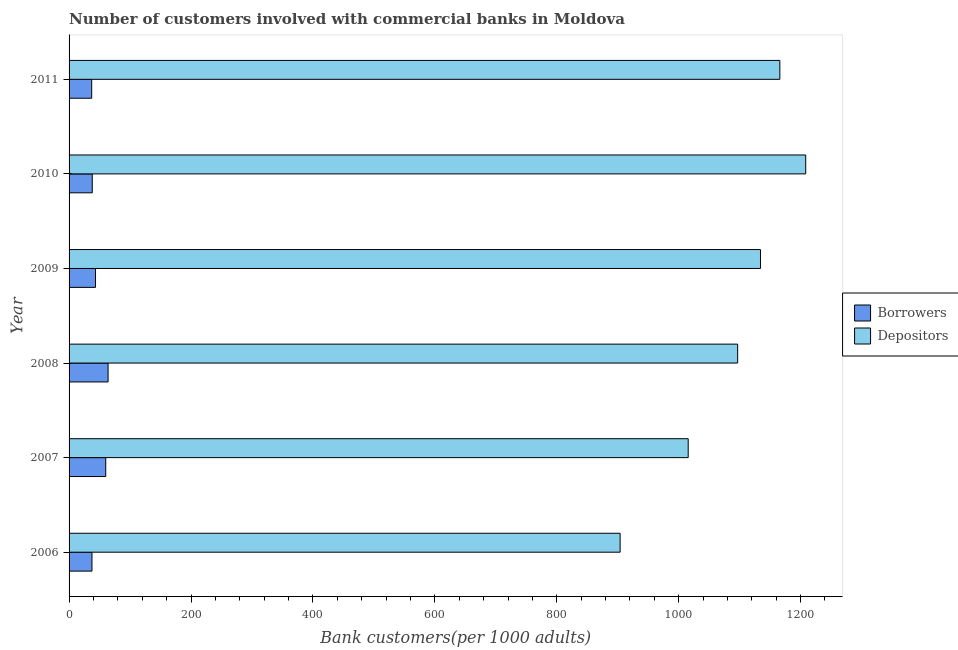How many groups of bars are there?
Your answer should be compact. 6. How many bars are there on the 4th tick from the bottom?
Make the answer very short. 2. What is the label of the 2nd group of bars from the top?
Your response must be concise. 2010. What is the number of borrowers in 2006?
Offer a very short reply. 37.56. Across all years, what is the maximum number of borrowers?
Keep it short and to the point. 63.99. Across all years, what is the minimum number of depositors?
Your answer should be very brief. 903.95. In which year was the number of depositors minimum?
Your response must be concise. 2006. What is the total number of depositors in the graph?
Ensure brevity in your answer.  6524.78. What is the difference between the number of borrowers in 2006 and that in 2007?
Your answer should be compact. -22.58. What is the difference between the number of depositors in 2006 and the number of borrowers in 2008?
Ensure brevity in your answer.  839.96. What is the average number of depositors per year?
Provide a succinct answer. 1087.46. In the year 2007, what is the difference between the number of borrowers and number of depositors?
Keep it short and to the point. -955.47. In how many years, is the number of depositors greater than 920 ?
Offer a very short reply. 5. What is the ratio of the number of borrowers in 2008 to that in 2010?
Your response must be concise. 1.68. What is the difference between the highest and the second highest number of depositors?
Provide a short and direct response. 42.46. What is the difference between the highest and the lowest number of depositors?
Offer a very short reply. 304.44. In how many years, is the number of borrowers greater than the average number of borrowers taken over all years?
Give a very brief answer. 2. Is the sum of the number of depositors in 2007 and 2010 greater than the maximum number of borrowers across all years?
Your response must be concise. Yes. What does the 2nd bar from the top in 2010 represents?
Ensure brevity in your answer.  Borrowers. What does the 1st bar from the bottom in 2008 represents?
Keep it short and to the point. Borrowers. How many bars are there?
Provide a succinct answer. 12. Are all the bars in the graph horizontal?
Provide a short and direct response. Yes. How many years are there in the graph?
Offer a terse response. 6. Are the values on the major ticks of X-axis written in scientific E-notation?
Give a very brief answer. No. Does the graph contain any zero values?
Offer a terse response. No. Does the graph contain grids?
Make the answer very short. No. How many legend labels are there?
Your answer should be compact. 2. What is the title of the graph?
Your answer should be very brief. Number of customers involved with commercial banks in Moldova. Does "% of GNI" appear as one of the legend labels in the graph?
Give a very brief answer. No. What is the label or title of the X-axis?
Make the answer very short. Bank customers(per 1000 adults). What is the label or title of the Y-axis?
Ensure brevity in your answer.  Year. What is the Bank customers(per 1000 adults) in Borrowers in 2006?
Give a very brief answer. 37.56. What is the Bank customers(per 1000 adults) in Depositors in 2006?
Your response must be concise. 903.95. What is the Bank customers(per 1000 adults) in Borrowers in 2007?
Provide a short and direct response. 60.13. What is the Bank customers(per 1000 adults) in Depositors in 2007?
Your response must be concise. 1015.6. What is the Bank customers(per 1000 adults) in Borrowers in 2008?
Offer a terse response. 63.99. What is the Bank customers(per 1000 adults) of Depositors in 2008?
Give a very brief answer. 1096.73. What is the Bank customers(per 1000 adults) in Borrowers in 2009?
Your answer should be compact. 43.38. What is the Bank customers(per 1000 adults) in Depositors in 2009?
Provide a short and direct response. 1134.17. What is the Bank customers(per 1000 adults) in Borrowers in 2010?
Make the answer very short. 38.03. What is the Bank customers(per 1000 adults) of Depositors in 2010?
Give a very brief answer. 1208.39. What is the Bank customers(per 1000 adults) in Borrowers in 2011?
Give a very brief answer. 37.11. What is the Bank customers(per 1000 adults) in Depositors in 2011?
Provide a short and direct response. 1165.93. Across all years, what is the maximum Bank customers(per 1000 adults) in Borrowers?
Offer a terse response. 63.99. Across all years, what is the maximum Bank customers(per 1000 adults) in Depositors?
Offer a very short reply. 1208.39. Across all years, what is the minimum Bank customers(per 1000 adults) in Borrowers?
Provide a succinct answer. 37.11. Across all years, what is the minimum Bank customers(per 1000 adults) of Depositors?
Offer a very short reply. 903.95. What is the total Bank customers(per 1000 adults) in Borrowers in the graph?
Your answer should be very brief. 280.21. What is the total Bank customers(per 1000 adults) of Depositors in the graph?
Your response must be concise. 6524.78. What is the difference between the Bank customers(per 1000 adults) of Borrowers in 2006 and that in 2007?
Your answer should be compact. -22.58. What is the difference between the Bank customers(per 1000 adults) in Depositors in 2006 and that in 2007?
Offer a very short reply. -111.65. What is the difference between the Bank customers(per 1000 adults) in Borrowers in 2006 and that in 2008?
Offer a terse response. -26.43. What is the difference between the Bank customers(per 1000 adults) in Depositors in 2006 and that in 2008?
Give a very brief answer. -192.78. What is the difference between the Bank customers(per 1000 adults) of Borrowers in 2006 and that in 2009?
Keep it short and to the point. -5.82. What is the difference between the Bank customers(per 1000 adults) in Depositors in 2006 and that in 2009?
Your answer should be very brief. -230.23. What is the difference between the Bank customers(per 1000 adults) of Borrowers in 2006 and that in 2010?
Offer a terse response. -0.48. What is the difference between the Bank customers(per 1000 adults) of Depositors in 2006 and that in 2010?
Offer a very short reply. -304.44. What is the difference between the Bank customers(per 1000 adults) in Borrowers in 2006 and that in 2011?
Offer a terse response. 0.44. What is the difference between the Bank customers(per 1000 adults) of Depositors in 2006 and that in 2011?
Your answer should be very brief. -261.98. What is the difference between the Bank customers(per 1000 adults) of Borrowers in 2007 and that in 2008?
Offer a terse response. -3.86. What is the difference between the Bank customers(per 1000 adults) of Depositors in 2007 and that in 2008?
Keep it short and to the point. -81.13. What is the difference between the Bank customers(per 1000 adults) of Borrowers in 2007 and that in 2009?
Keep it short and to the point. 16.76. What is the difference between the Bank customers(per 1000 adults) of Depositors in 2007 and that in 2009?
Your answer should be very brief. -118.57. What is the difference between the Bank customers(per 1000 adults) of Borrowers in 2007 and that in 2010?
Make the answer very short. 22.1. What is the difference between the Bank customers(per 1000 adults) of Depositors in 2007 and that in 2010?
Provide a succinct answer. -192.79. What is the difference between the Bank customers(per 1000 adults) of Borrowers in 2007 and that in 2011?
Provide a succinct answer. 23.02. What is the difference between the Bank customers(per 1000 adults) in Depositors in 2007 and that in 2011?
Provide a succinct answer. -150.33. What is the difference between the Bank customers(per 1000 adults) in Borrowers in 2008 and that in 2009?
Your answer should be compact. 20.61. What is the difference between the Bank customers(per 1000 adults) in Depositors in 2008 and that in 2009?
Provide a succinct answer. -37.44. What is the difference between the Bank customers(per 1000 adults) in Borrowers in 2008 and that in 2010?
Your response must be concise. 25.95. What is the difference between the Bank customers(per 1000 adults) of Depositors in 2008 and that in 2010?
Give a very brief answer. -111.66. What is the difference between the Bank customers(per 1000 adults) in Borrowers in 2008 and that in 2011?
Offer a very short reply. 26.87. What is the difference between the Bank customers(per 1000 adults) of Depositors in 2008 and that in 2011?
Keep it short and to the point. -69.2. What is the difference between the Bank customers(per 1000 adults) in Borrowers in 2009 and that in 2010?
Make the answer very short. 5.34. What is the difference between the Bank customers(per 1000 adults) of Depositors in 2009 and that in 2010?
Offer a very short reply. -74.22. What is the difference between the Bank customers(per 1000 adults) of Borrowers in 2009 and that in 2011?
Your answer should be compact. 6.26. What is the difference between the Bank customers(per 1000 adults) in Depositors in 2009 and that in 2011?
Offer a very short reply. -31.76. What is the difference between the Bank customers(per 1000 adults) in Borrowers in 2010 and that in 2011?
Your answer should be compact. 0.92. What is the difference between the Bank customers(per 1000 adults) in Depositors in 2010 and that in 2011?
Your response must be concise. 42.46. What is the difference between the Bank customers(per 1000 adults) of Borrowers in 2006 and the Bank customers(per 1000 adults) of Depositors in 2007?
Provide a short and direct response. -978.04. What is the difference between the Bank customers(per 1000 adults) of Borrowers in 2006 and the Bank customers(per 1000 adults) of Depositors in 2008?
Provide a short and direct response. -1059.17. What is the difference between the Bank customers(per 1000 adults) of Borrowers in 2006 and the Bank customers(per 1000 adults) of Depositors in 2009?
Provide a short and direct response. -1096.62. What is the difference between the Bank customers(per 1000 adults) of Borrowers in 2006 and the Bank customers(per 1000 adults) of Depositors in 2010?
Your response must be concise. -1170.83. What is the difference between the Bank customers(per 1000 adults) in Borrowers in 2006 and the Bank customers(per 1000 adults) in Depositors in 2011?
Your answer should be very brief. -1128.37. What is the difference between the Bank customers(per 1000 adults) in Borrowers in 2007 and the Bank customers(per 1000 adults) in Depositors in 2008?
Offer a very short reply. -1036.6. What is the difference between the Bank customers(per 1000 adults) in Borrowers in 2007 and the Bank customers(per 1000 adults) in Depositors in 2009?
Your answer should be very brief. -1074.04. What is the difference between the Bank customers(per 1000 adults) of Borrowers in 2007 and the Bank customers(per 1000 adults) of Depositors in 2010?
Your response must be concise. -1148.26. What is the difference between the Bank customers(per 1000 adults) in Borrowers in 2007 and the Bank customers(per 1000 adults) in Depositors in 2011?
Ensure brevity in your answer.  -1105.8. What is the difference between the Bank customers(per 1000 adults) of Borrowers in 2008 and the Bank customers(per 1000 adults) of Depositors in 2009?
Provide a succinct answer. -1070.19. What is the difference between the Bank customers(per 1000 adults) of Borrowers in 2008 and the Bank customers(per 1000 adults) of Depositors in 2010?
Make the answer very short. -1144.4. What is the difference between the Bank customers(per 1000 adults) of Borrowers in 2008 and the Bank customers(per 1000 adults) of Depositors in 2011?
Make the answer very short. -1101.94. What is the difference between the Bank customers(per 1000 adults) in Borrowers in 2009 and the Bank customers(per 1000 adults) in Depositors in 2010?
Keep it short and to the point. -1165.01. What is the difference between the Bank customers(per 1000 adults) in Borrowers in 2009 and the Bank customers(per 1000 adults) in Depositors in 2011?
Give a very brief answer. -1122.55. What is the difference between the Bank customers(per 1000 adults) of Borrowers in 2010 and the Bank customers(per 1000 adults) of Depositors in 2011?
Provide a short and direct response. -1127.9. What is the average Bank customers(per 1000 adults) of Borrowers per year?
Offer a very short reply. 46.7. What is the average Bank customers(per 1000 adults) of Depositors per year?
Provide a short and direct response. 1087.46. In the year 2006, what is the difference between the Bank customers(per 1000 adults) in Borrowers and Bank customers(per 1000 adults) in Depositors?
Provide a short and direct response. -866.39. In the year 2007, what is the difference between the Bank customers(per 1000 adults) of Borrowers and Bank customers(per 1000 adults) of Depositors?
Give a very brief answer. -955.47. In the year 2008, what is the difference between the Bank customers(per 1000 adults) of Borrowers and Bank customers(per 1000 adults) of Depositors?
Make the answer very short. -1032.74. In the year 2009, what is the difference between the Bank customers(per 1000 adults) of Borrowers and Bank customers(per 1000 adults) of Depositors?
Offer a very short reply. -1090.8. In the year 2010, what is the difference between the Bank customers(per 1000 adults) of Borrowers and Bank customers(per 1000 adults) of Depositors?
Your answer should be compact. -1170.36. In the year 2011, what is the difference between the Bank customers(per 1000 adults) in Borrowers and Bank customers(per 1000 adults) in Depositors?
Provide a short and direct response. -1128.82. What is the ratio of the Bank customers(per 1000 adults) of Borrowers in 2006 to that in 2007?
Your answer should be compact. 0.62. What is the ratio of the Bank customers(per 1000 adults) of Depositors in 2006 to that in 2007?
Give a very brief answer. 0.89. What is the ratio of the Bank customers(per 1000 adults) of Borrowers in 2006 to that in 2008?
Offer a terse response. 0.59. What is the ratio of the Bank customers(per 1000 adults) of Depositors in 2006 to that in 2008?
Provide a succinct answer. 0.82. What is the ratio of the Bank customers(per 1000 adults) in Borrowers in 2006 to that in 2009?
Your response must be concise. 0.87. What is the ratio of the Bank customers(per 1000 adults) of Depositors in 2006 to that in 2009?
Keep it short and to the point. 0.8. What is the ratio of the Bank customers(per 1000 adults) in Borrowers in 2006 to that in 2010?
Your response must be concise. 0.99. What is the ratio of the Bank customers(per 1000 adults) of Depositors in 2006 to that in 2010?
Offer a terse response. 0.75. What is the ratio of the Bank customers(per 1000 adults) of Depositors in 2006 to that in 2011?
Keep it short and to the point. 0.78. What is the ratio of the Bank customers(per 1000 adults) in Borrowers in 2007 to that in 2008?
Your answer should be compact. 0.94. What is the ratio of the Bank customers(per 1000 adults) of Depositors in 2007 to that in 2008?
Provide a succinct answer. 0.93. What is the ratio of the Bank customers(per 1000 adults) in Borrowers in 2007 to that in 2009?
Your answer should be very brief. 1.39. What is the ratio of the Bank customers(per 1000 adults) of Depositors in 2007 to that in 2009?
Keep it short and to the point. 0.9. What is the ratio of the Bank customers(per 1000 adults) in Borrowers in 2007 to that in 2010?
Provide a short and direct response. 1.58. What is the ratio of the Bank customers(per 1000 adults) of Depositors in 2007 to that in 2010?
Provide a short and direct response. 0.84. What is the ratio of the Bank customers(per 1000 adults) of Borrowers in 2007 to that in 2011?
Provide a short and direct response. 1.62. What is the ratio of the Bank customers(per 1000 adults) in Depositors in 2007 to that in 2011?
Provide a succinct answer. 0.87. What is the ratio of the Bank customers(per 1000 adults) of Borrowers in 2008 to that in 2009?
Ensure brevity in your answer.  1.48. What is the ratio of the Bank customers(per 1000 adults) in Depositors in 2008 to that in 2009?
Provide a succinct answer. 0.97. What is the ratio of the Bank customers(per 1000 adults) in Borrowers in 2008 to that in 2010?
Your answer should be very brief. 1.68. What is the ratio of the Bank customers(per 1000 adults) in Depositors in 2008 to that in 2010?
Make the answer very short. 0.91. What is the ratio of the Bank customers(per 1000 adults) of Borrowers in 2008 to that in 2011?
Provide a succinct answer. 1.72. What is the ratio of the Bank customers(per 1000 adults) in Depositors in 2008 to that in 2011?
Offer a very short reply. 0.94. What is the ratio of the Bank customers(per 1000 adults) in Borrowers in 2009 to that in 2010?
Make the answer very short. 1.14. What is the ratio of the Bank customers(per 1000 adults) of Depositors in 2009 to that in 2010?
Offer a terse response. 0.94. What is the ratio of the Bank customers(per 1000 adults) of Borrowers in 2009 to that in 2011?
Provide a short and direct response. 1.17. What is the ratio of the Bank customers(per 1000 adults) in Depositors in 2009 to that in 2011?
Offer a very short reply. 0.97. What is the ratio of the Bank customers(per 1000 adults) in Borrowers in 2010 to that in 2011?
Ensure brevity in your answer.  1.02. What is the ratio of the Bank customers(per 1000 adults) of Depositors in 2010 to that in 2011?
Provide a short and direct response. 1.04. What is the difference between the highest and the second highest Bank customers(per 1000 adults) of Borrowers?
Offer a very short reply. 3.86. What is the difference between the highest and the second highest Bank customers(per 1000 adults) in Depositors?
Provide a succinct answer. 42.46. What is the difference between the highest and the lowest Bank customers(per 1000 adults) of Borrowers?
Your response must be concise. 26.87. What is the difference between the highest and the lowest Bank customers(per 1000 adults) in Depositors?
Provide a short and direct response. 304.44. 